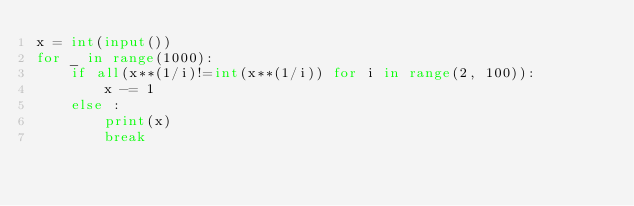Convert code to text. <code><loc_0><loc_0><loc_500><loc_500><_Python_>x = int(input())
for _ in range(1000):
    if all(x**(1/i)!=int(x**(1/i)) for i in range(2, 100)):
        x -= 1
    else :
        print(x)
        break
</code> 